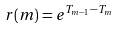Convert formula to latex. <formula><loc_0><loc_0><loc_500><loc_500>r ( m ) = e ^ { T _ { m - 1 } - T _ { m } }</formula> 